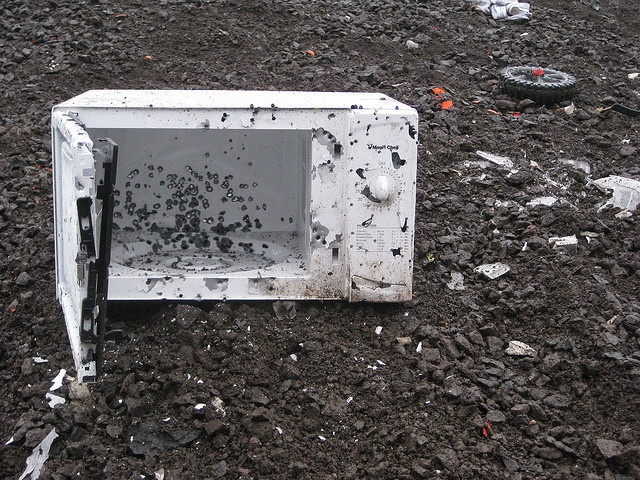Describe the objects in this image and their specific colors. I can see a microwave in black, lightgray, gray, and darkgray tones in this image. 